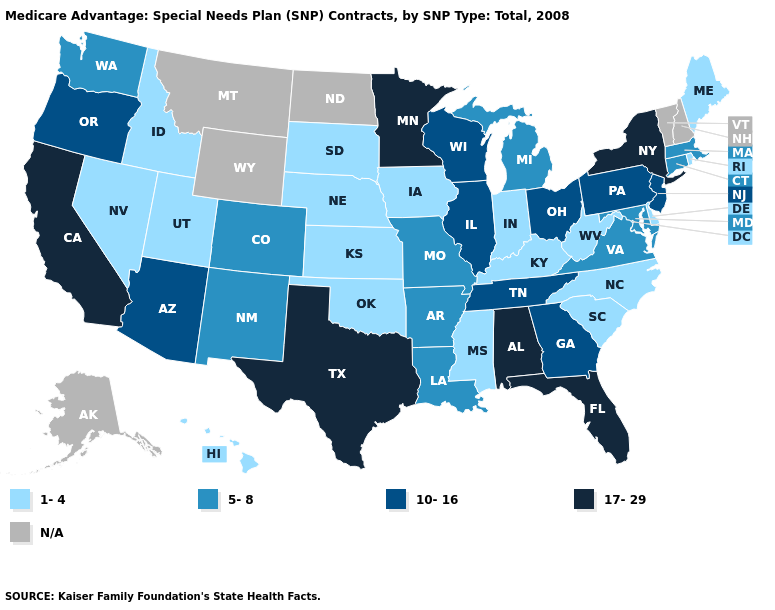Name the states that have a value in the range 10-16?
Write a very short answer. Arizona, Georgia, Illinois, New Jersey, Ohio, Oregon, Pennsylvania, Tennessee, Wisconsin. Does the first symbol in the legend represent the smallest category?
Quick response, please. Yes. Name the states that have a value in the range 1-4?
Answer briefly. Delaware, Hawaii, Iowa, Idaho, Indiana, Kansas, Kentucky, Maine, Mississippi, North Carolina, Nebraska, Nevada, Oklahoma, Rhode Island, South Carolina, South Dakota, Utah, West Virginia. Among the states that border Connecticut , does New York have the highest value?
Answer briefly. Yes. What is the value of Connecticut?
Answer briefly. 5-8. Name the states that have a value in the range 5-8?
Write a very short answer. Arkansas, Colorado, Connecticut, Louisiana, Massachusetts, Maryland, Michigan, Missouri, New Mexico, Virginia, Washington. Is the legend a continuous bar?
Concise answer only. No. Among the states that border Virginia , does West Virginia have the highest value?
Short answer required. No. Which states have the lowest value in the USA?
Keep it brief. Delaware, Hawaii, Iowa, Idaho, Indiana, Kansas, Kentucky, Maine, Mississippi, North Carolina, Nebraska, Nevada, Oklahoma, Rhode Island, South Carolina, South Dakota, Utah, West Virginia. Does Delaware have the lowest value in the South?
Keep it brief. Yes. What is the highest value in the Northeast ?
Give a very brief answer. 17-29. Does Indiana have the lowest value in the MidWest?
Short answer required. Yes. What is the lowest value in states that border Minnesota?
Answer briefly. 1-4. 